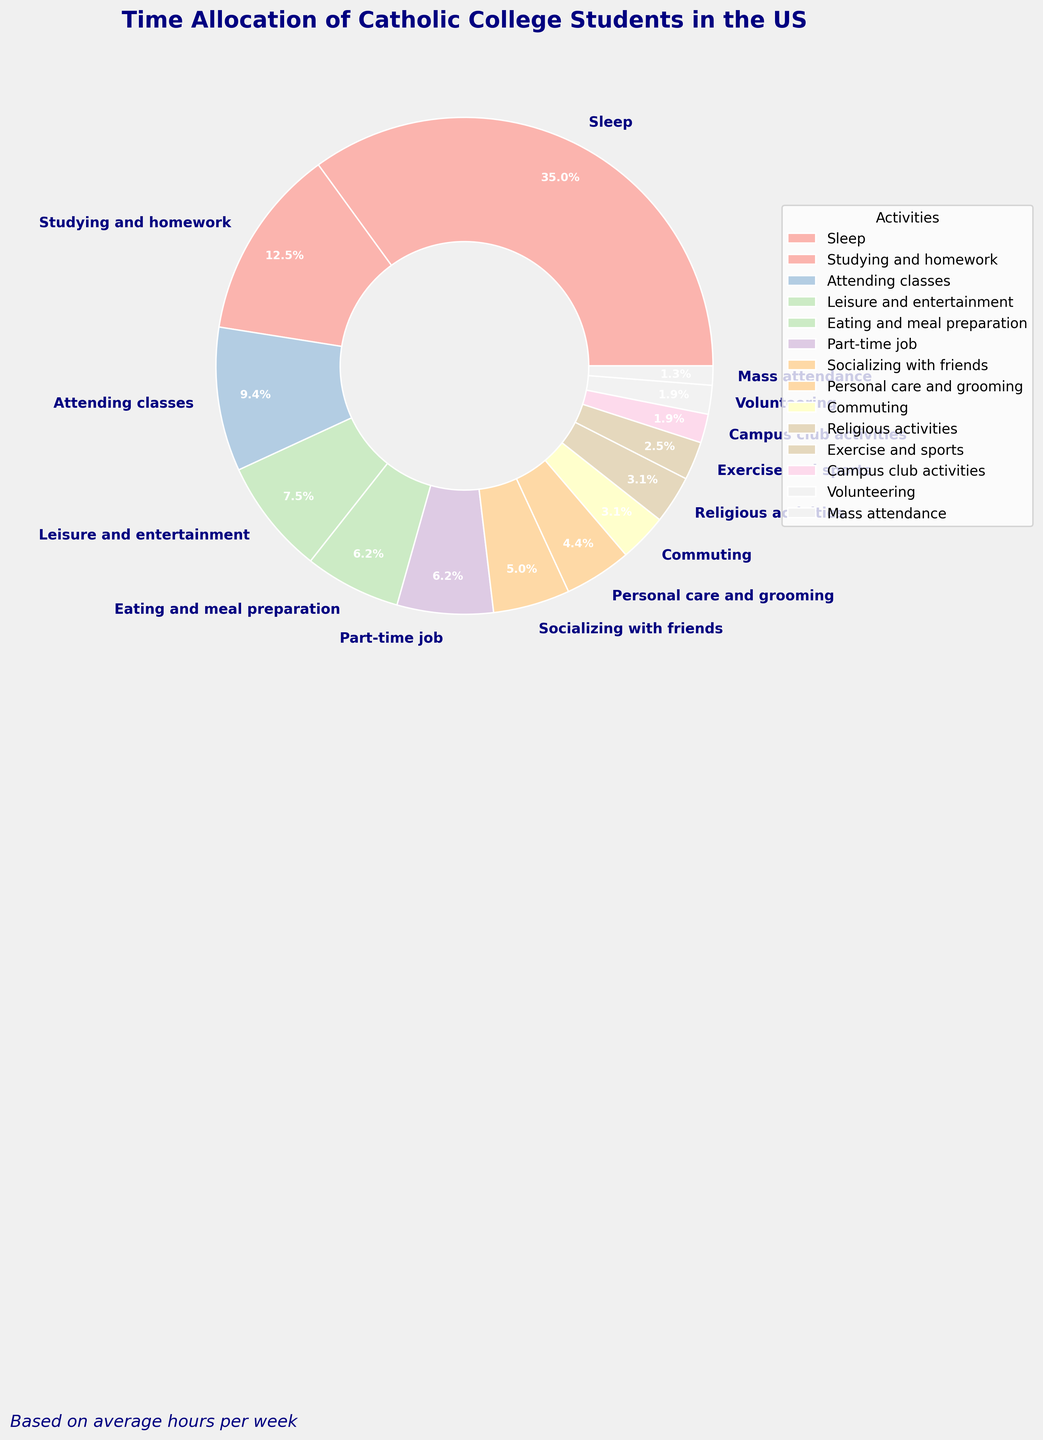Which activity do Catholic college students spend the most time on per week? By referring to the pie chart, observe the segment with the largest percentage. The "Sleep" segment at 33.3% is the largest.
Answer: Sleep Which two activities combined take up the same percentage of time as attending classes? "Attending classes" takes 8.9% of the time. By looking at the chart, the segments for "Exercise and sports" (2.4%) and "Volunteering" (1.8%) together total 4.2%, which, when added to "Campus club activities" (1.8%), results in approximately 8.4%, which closely matches the percentage for attending classes.
Answer: Exercise and sports, Volunteering, and Campus club activities How much more time is spent on studying and homework compared to part-time jobs? The pie chart shows "Studying and homework" at 11.9% and "Part-time job" at 6.0%. Subtracting these values gives the difference (11.9% - 6.0% = 5.9%).
Answer: 5.9% What is the total percentage of time dedicated to religious and mass attendance activities? Add the percentages for "Religious activities" (3.0%) and "Mass attendance" (1.2%). 3.0% + 1.2% = 4.2%.
Answer: 4.2% Which activity occupies nearly the same proportion of time as personal care and grooming? "Personal care and grooming" occupies 4.2%. By comparing the chart, "Commuting," which takes up 3.0%, is close to this proportion.
Answer: Commuting Does socializing with friends take up more time than eating and meal preparation? The chart shows "Socializing with friends" at 4.8% and "Eating and meal preparation" at 6.0%. Since 4.8% < 6.0%, socializing does not take up more time.
Answer: No Rank the top three activities based on the percentage of time spent. The highest percentages in descending order are for "Sleep" (33.3%), "Studying and homework" (11.9%), and "Leisure and entertainment" (7.1%).
Answer: Sleep, Studying and homework, Leisure and entertainment Calculate the percentage of time spent on leisure and entertainment, volunteering, and campus club activities combined. Add the percentages: "Leisure and entertainment" (7.1%), "Volunteering" (1.8%), and "Campus club activities" (1.8%). 7.1% + 1.8% + 1.8% = 10.7%.
Answer: 10.7% Which activity is displayed in a visually distinctive font or style in the legend? The pie chart text and legend use a bolder and larger font, especially for the "Sleep" segment, which is the largest and most emphasized.
Answer: Sleep 